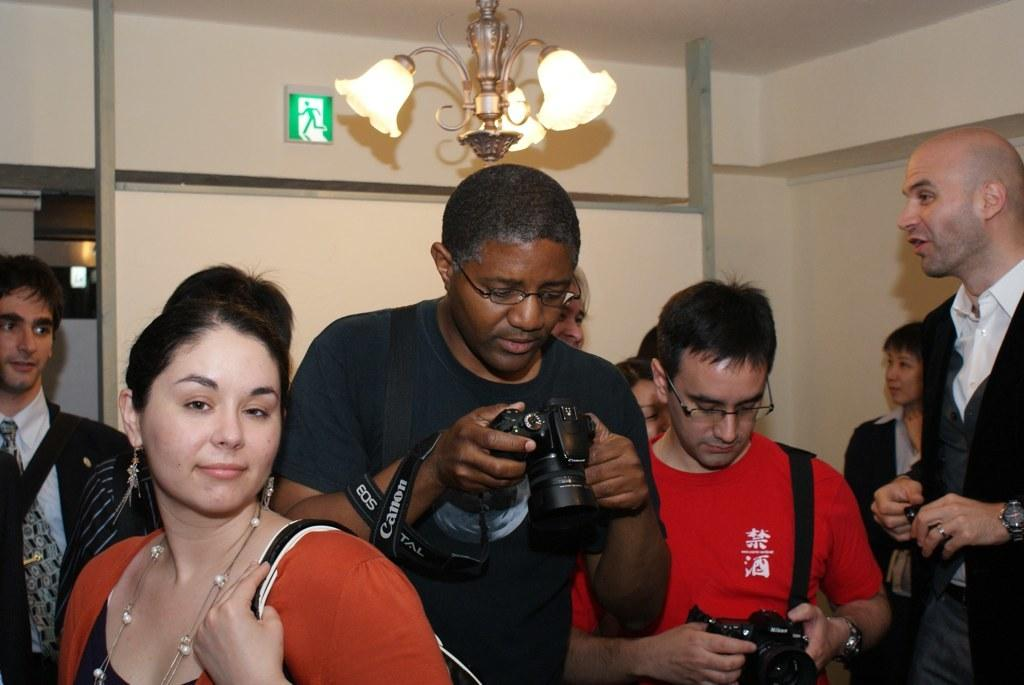How many people are present in the image? There are many people in the image. Can you describe any accessories that some people are wearing? Some people are wearing glasses (specs) in the image. What are some people holding in the image? Some people are holding bags and cameras in the image. What can be seen in the background of the image? There is a wall in the background of the image, and a sign board is on the wall. What type of lighting fixture is present in the image? There is a chandelier in the image. Is there a discussion taking place near the water in the image? There is no water or discussion present in the image; it features a group of people, some of whom are holding bags and cameras, with a wall and a sign board in the background. 